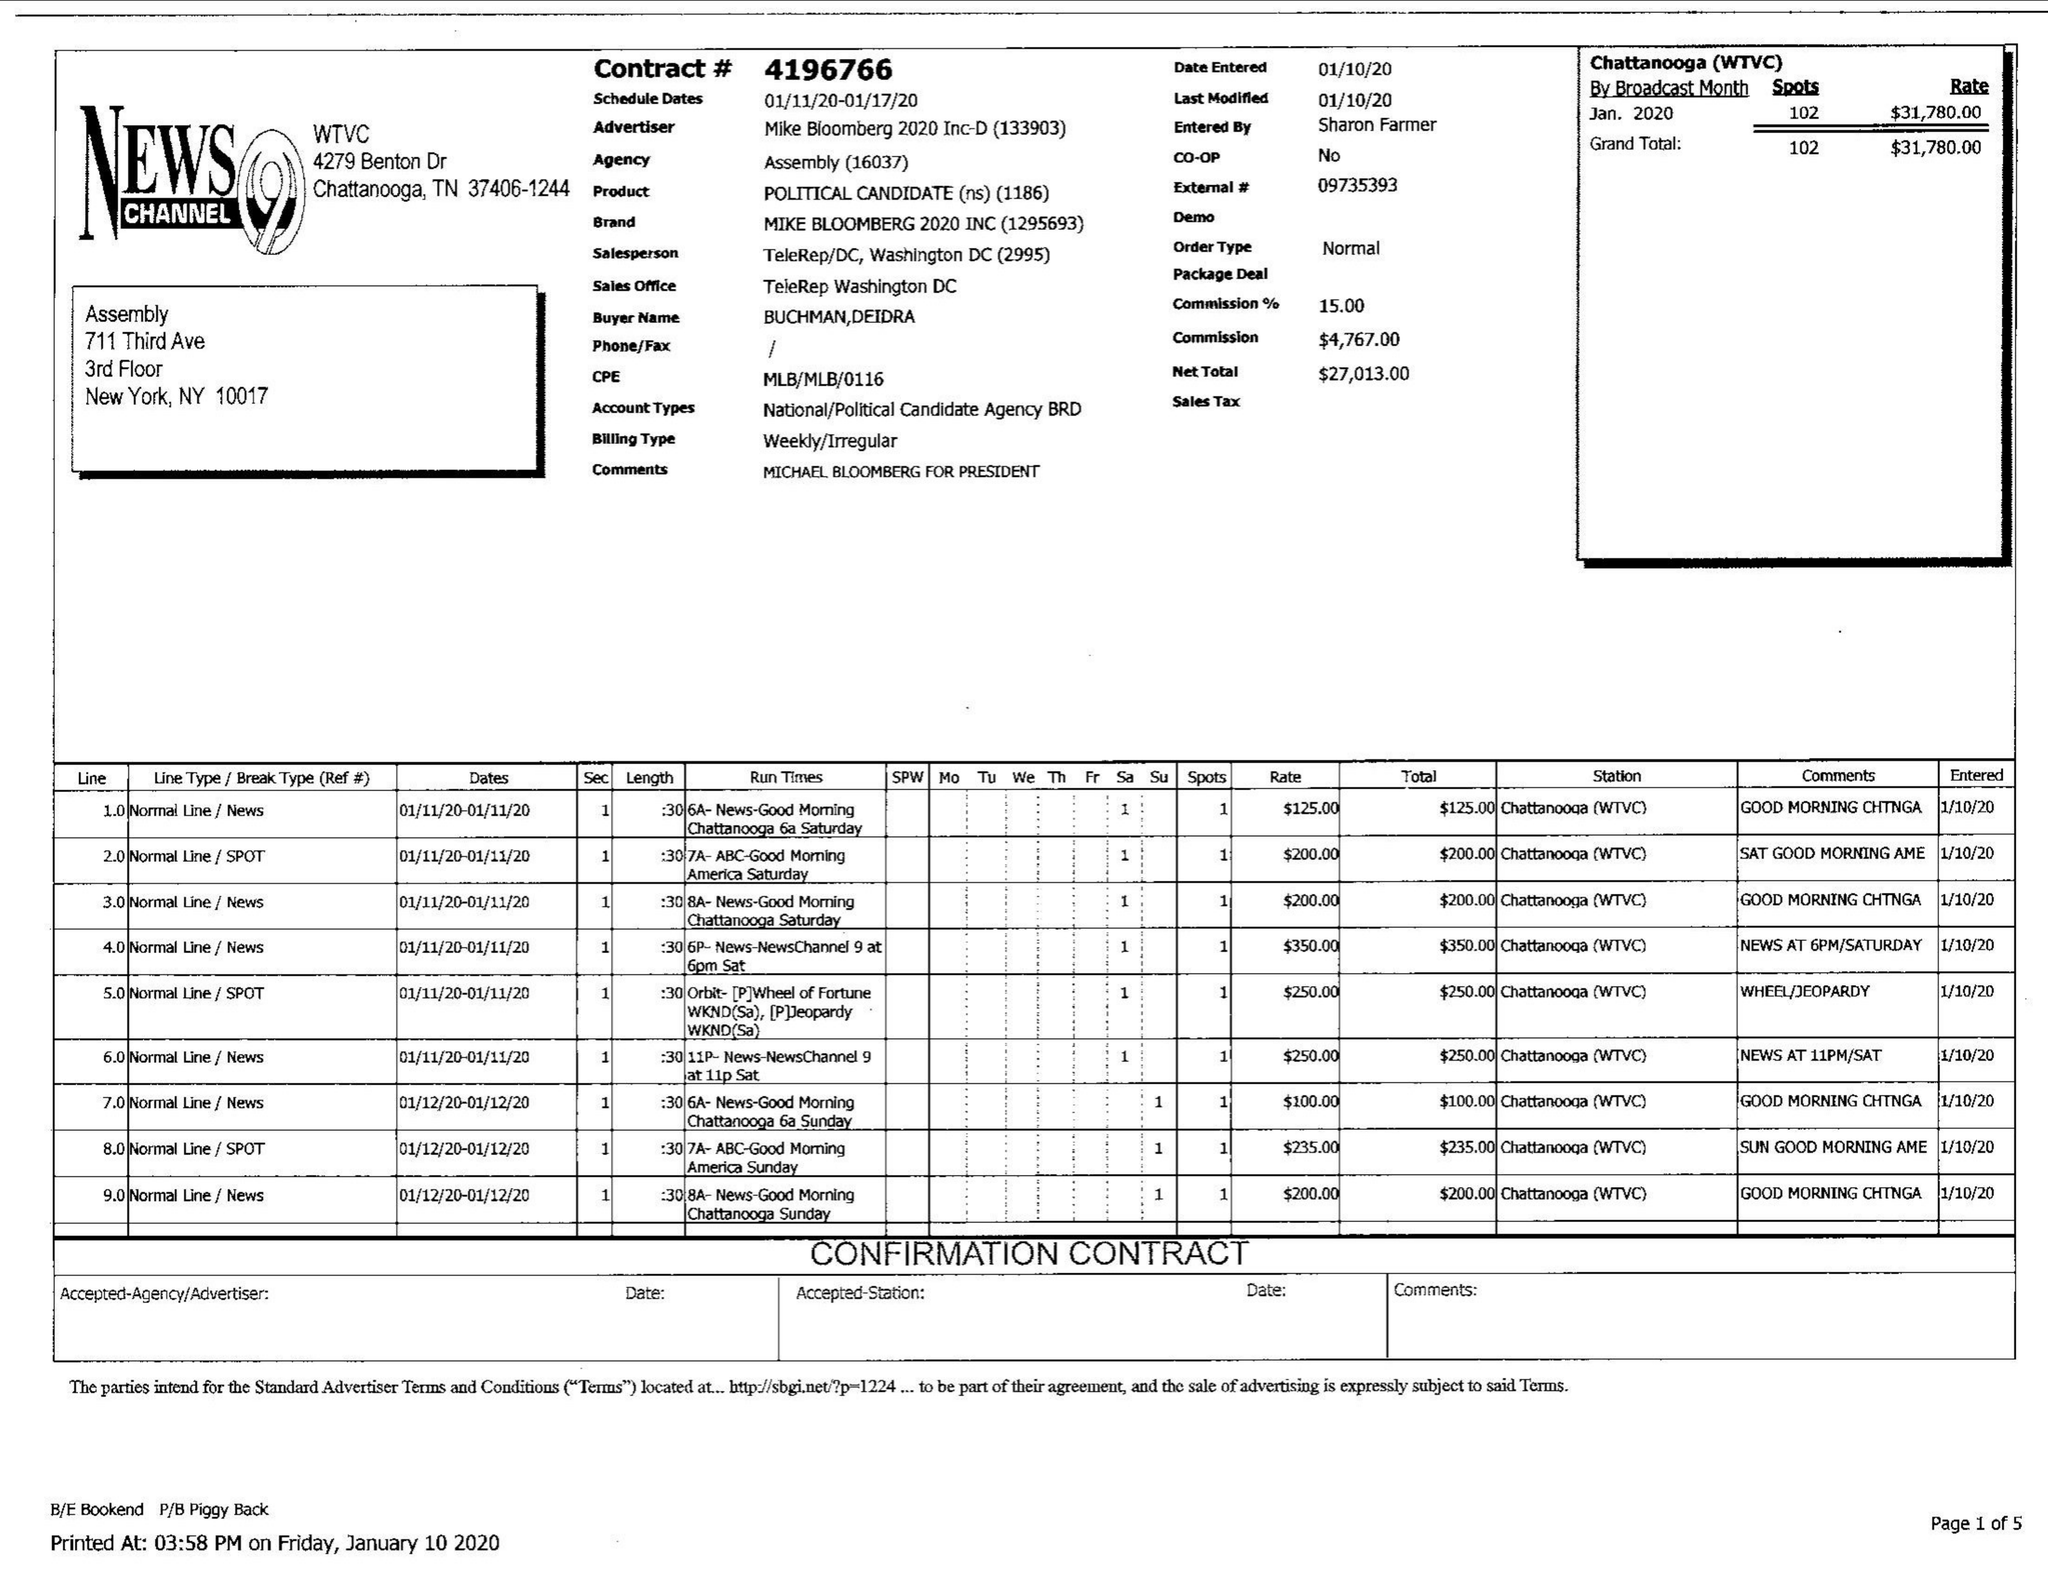What is the value for the advertiser?
Answer the question using a single word or phrase. KE BLOOMBERG 2020 INC 